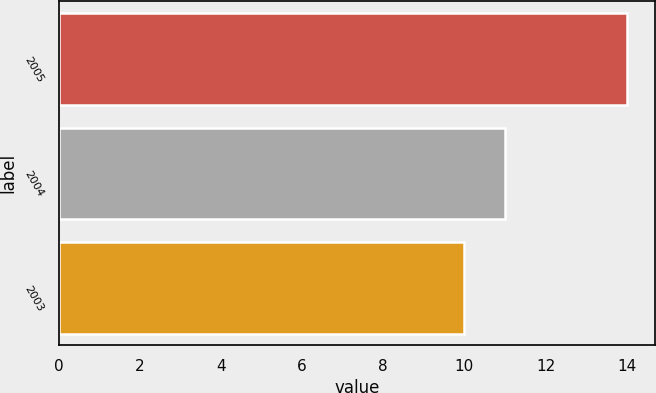<chart> <loc_0><loc_0><loc_500><loc_500><bar_chart><fcel>2005<fcel>2004<fcel>2003<nl><fcel>14<fcel>11<fcel>10<nl></chart> 